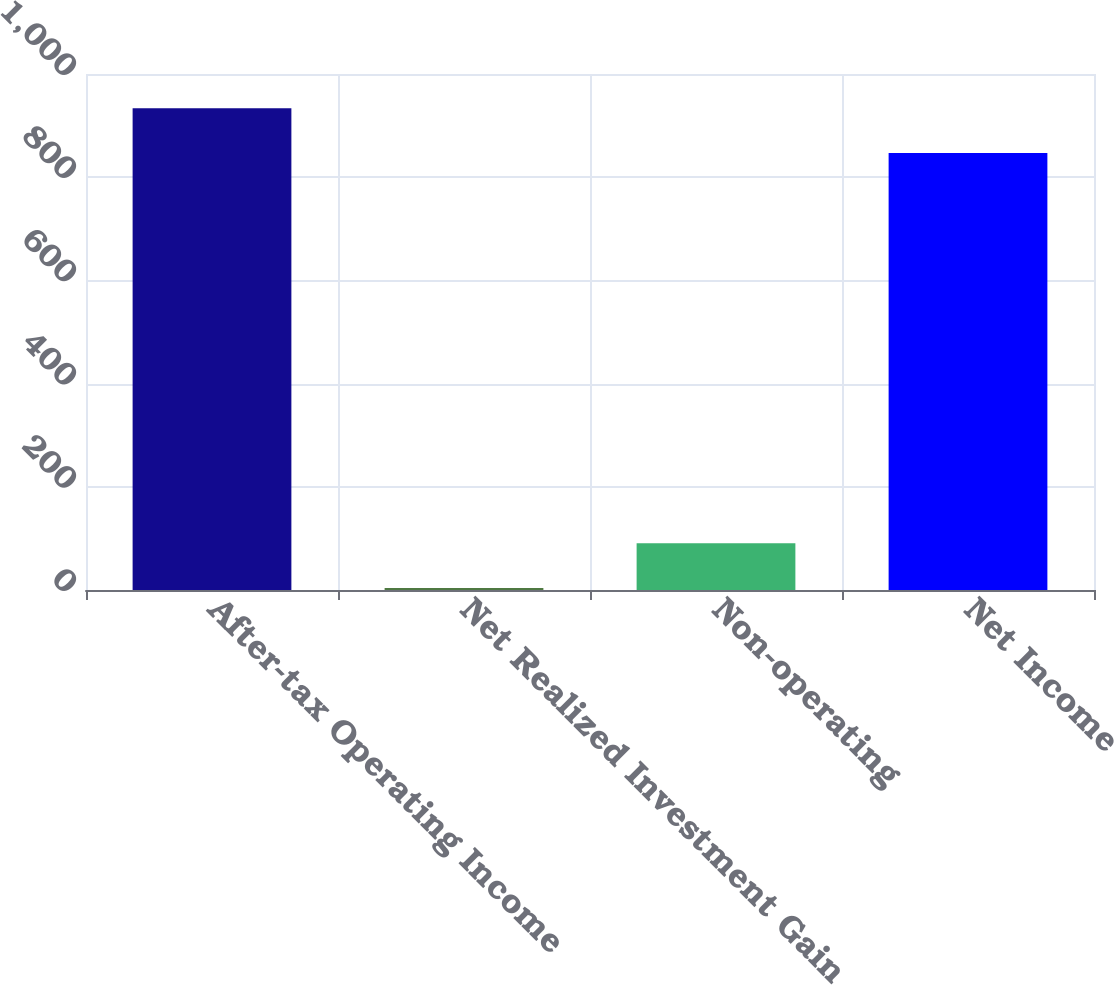Convert chart. <chart><loc_0><loc_0><loc_500><loc_500><bar_chart><fcel>After-tax Operating Income<fcel>Net Realized Investment Gain<fcel>Non-operating<fcel>Net Income<nl><fcel>933.75<fcel>3.9<fcel>90.65<fcel>847<nl></chart> 